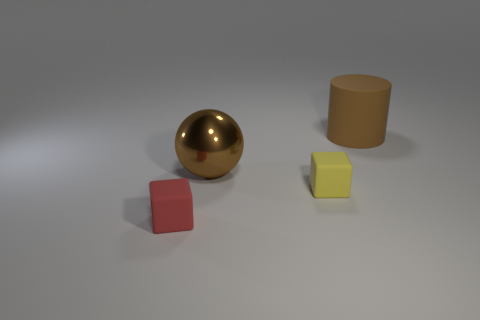Subtract 1 balls. How many balls are left? 0 Subtract all spheres. How many objects are left? 3 Add 2 large brown metallic balls. How many objects exist? 6 Subtract all brown rubber cylinders. Subtract all brown cylinders. How many objects are left? 2 Add 2 tiny yellow objects. How many tiny yellow objects are left? 3 Add 3 small yellow things. How many small yellow things exist? 4 Subtract 0 gray blocks. How many objects are left? 4 Subtract all blue blocks. Subtract all green cylinders. How many blocks are left? 2 Subtract all purple cylinders. How many red cubes are left? 1 